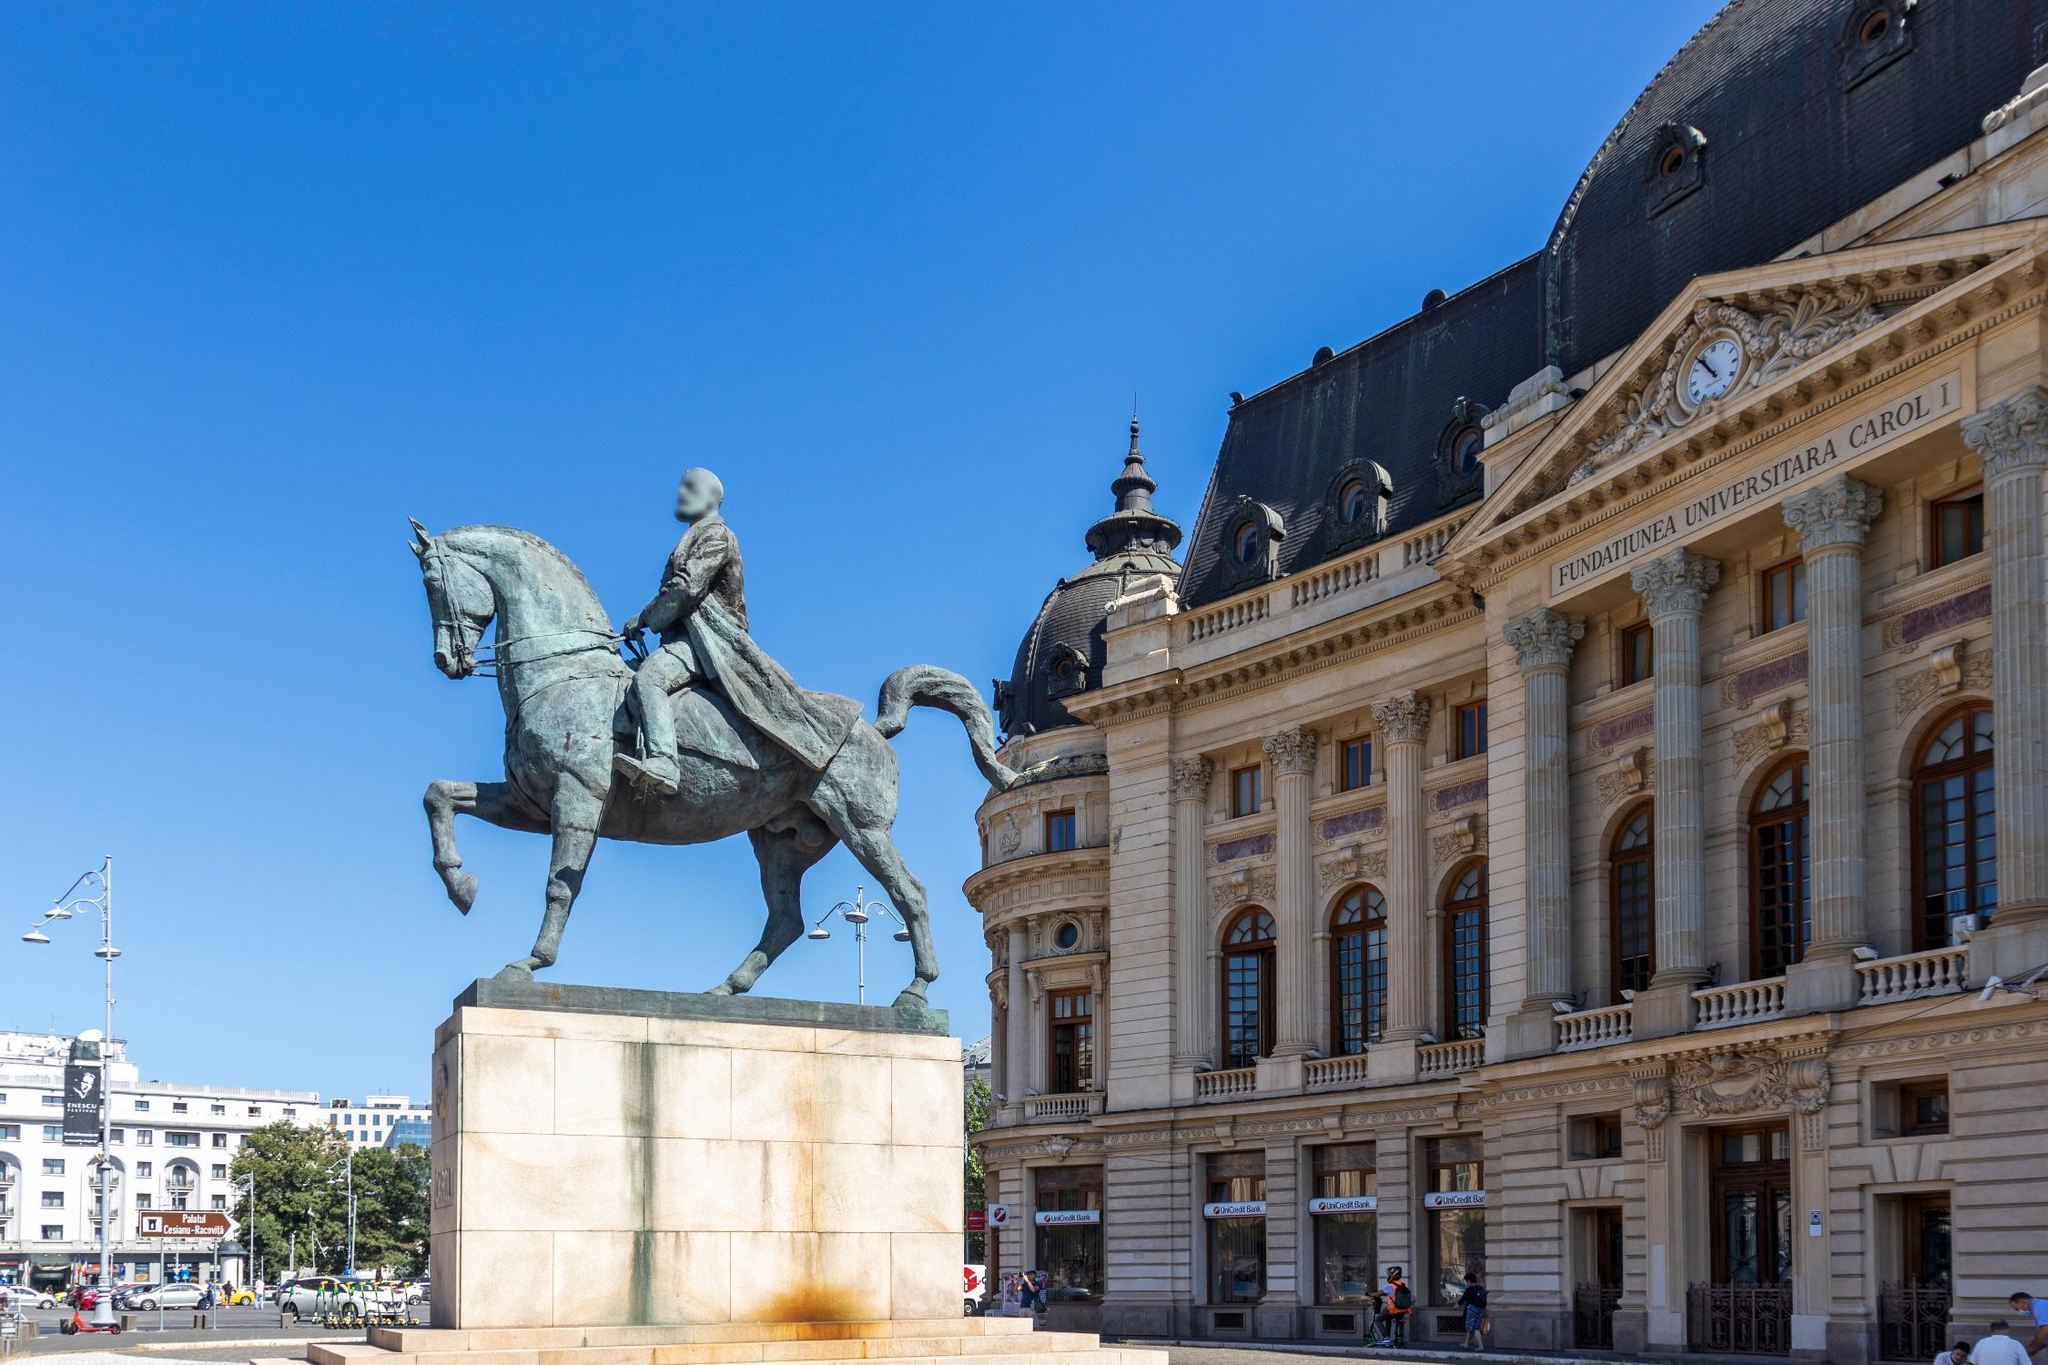What kind of stories could these structures tell us if they could speak? If these structures could speak, they would recount tales of empires and leaders, of monumental decisions made under the shadows they cast. The statue would narrate the battle cries and victories, the strategies devised from atop its horse. It would share the resilience of the people it represents, the hopes and dreams of a nation striving for greatness.

The building, with its grand neoclassical facade, would speak of the intellectual and cultural gatherings it has witnessed. It would whisper secrets of scholarly pursuits, political discourses, and artistic expressions that have shaped the identity of the society. Its walls, having borne witness to countless events, would echo with the footsteps of those who walked its halls—the influential and the ordinary who left their marks on history. What if a ghostly figure appeared in the background? How would that change your perception of the image? If a ghostly figure appeared in the background, it would add an eerie and mysterious layer to the image. The spectral presence could signify an unresolved past or a lingering spirit connected to the historical events represented by the statue. It would evoke curiosity and a sense of the supernatural, prompting viewers to wonder about the stories and secrets encapsulated within this space. The combination of the imposing statue, the grand building, and the ghostly apparition would create a chilling yet intriguing tableau, blending historical grandeur with the mysticism of the unknown. 